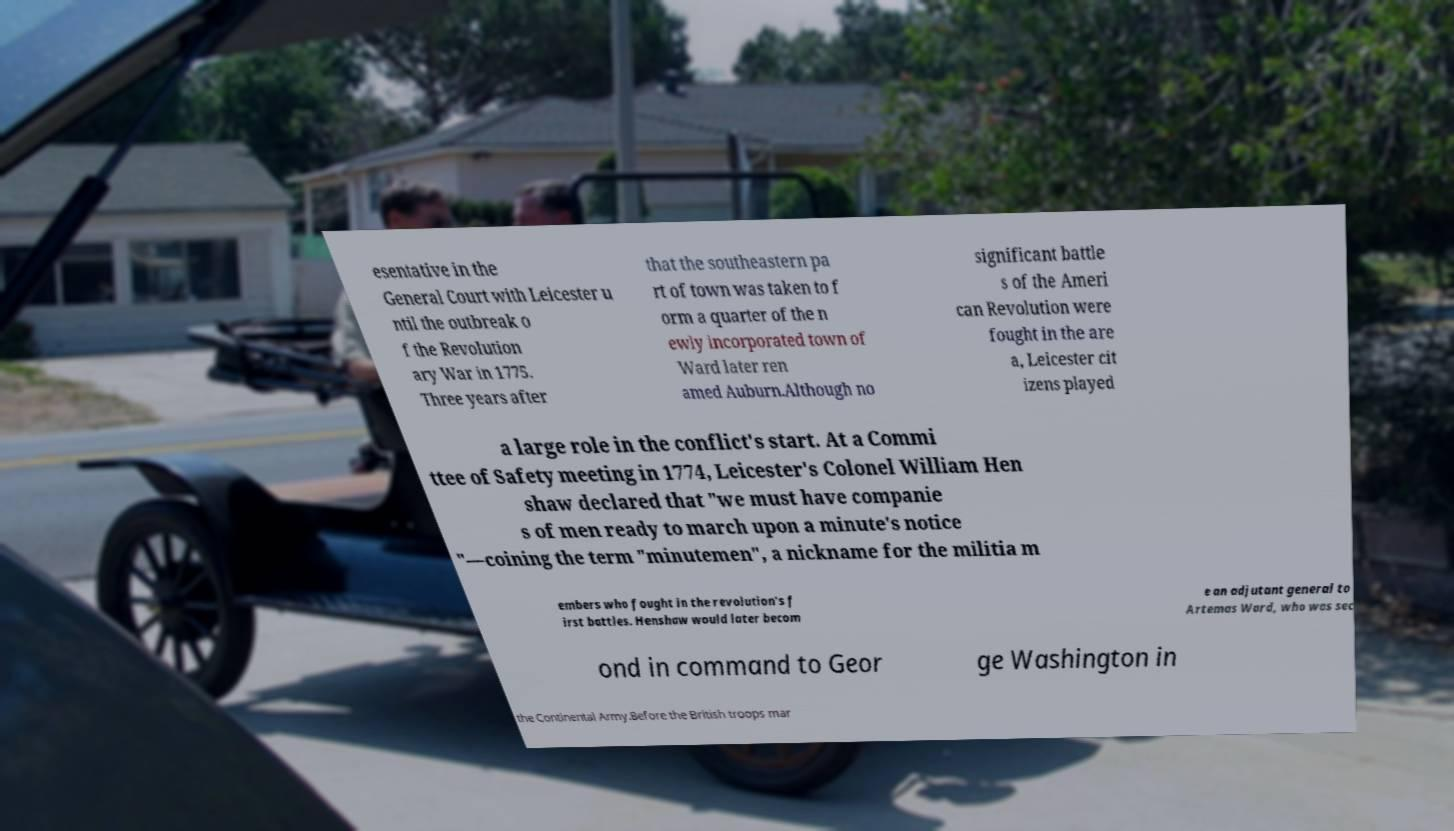Can you read and provide the text displayed in the image?This photo seems to have some interesting text. Can you extract and type it out for me? esentative in the General Court with Leicester u ntil the outbreak o f the Revolution ary War in 1775. Three years after that the southeastern pa rt of town was taken to f orm a quarter of the n ewly incorporated town of Ward later ren amed Auburn.Although no significant battle s of the Ameri can Revolution were fought in the are a, Leicester cit izens played a large role in the conflict's start. At a Commi ttee of Safety meeting in 1774, Leicester's Colonel William Hen shaw declared that "we must have companie s of men ready to march upon a minute's notice "—coining the term "minutemen", a nickname for the militia m embers who fought in the revolution's f irst battles. Henshaw would later becom e an adjutant general to Artemas Ward, who was sec ond in command to Geor ge Washington in the Continental Army.Before the British troops mar 